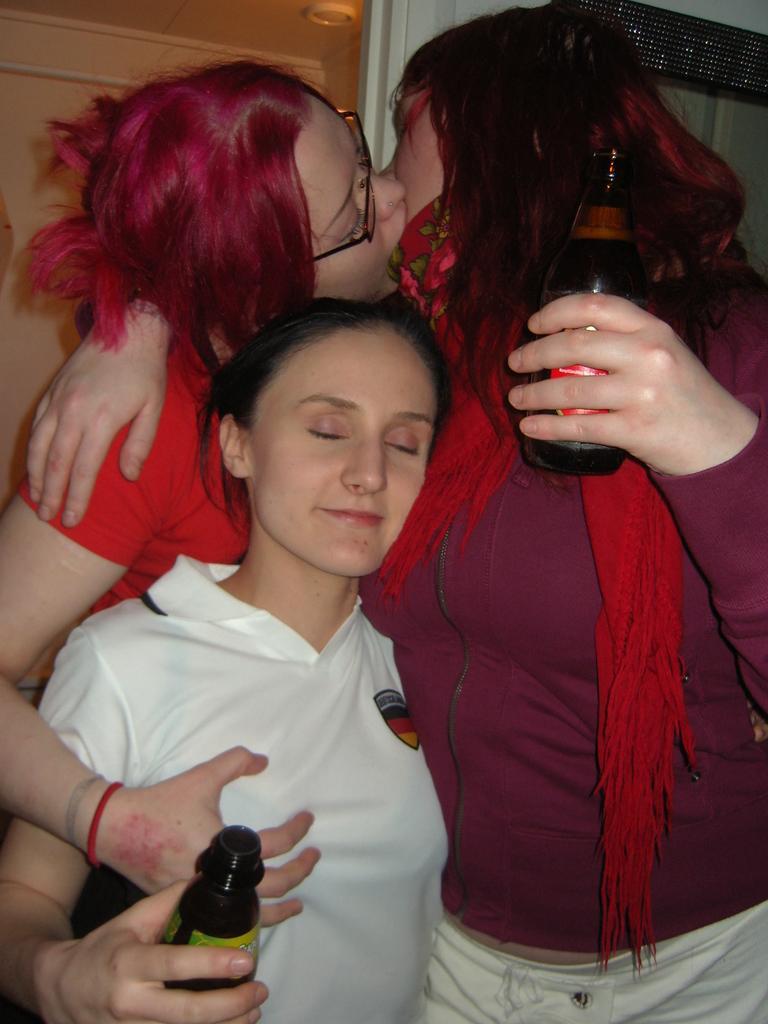Describe this image in one or two sentences. In the image we can see there are women who are standing and holding a wine glass in their hand. 